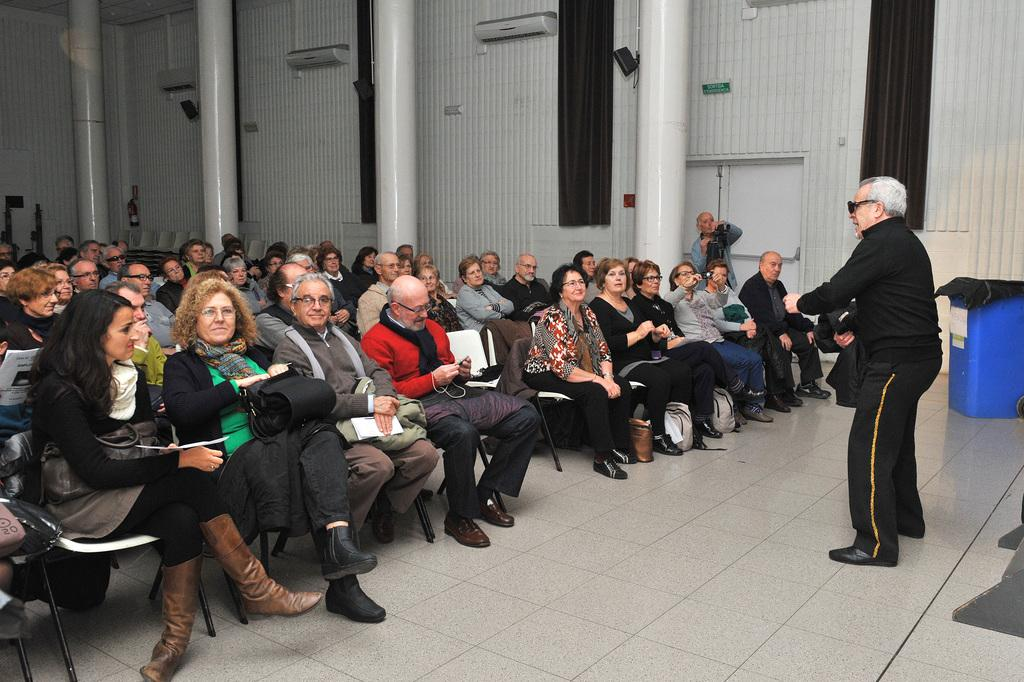What are the people in the image doing? There is a group of persons sitting on chairs in the image. Can you describe the man's position in the image? There is a man standing on the right side of the image. What can be seen in the background of the image? There is a wall, a curtain, a pillar, and a dustbin in the background of the image. What type of pear can be seen hanging from the string in the image? There is no pear or string present in the image. How does the taste of the dustbin contribute to the overall atmosphere of the image? The dustbin does not have a taste, as it is an inanimate object. 